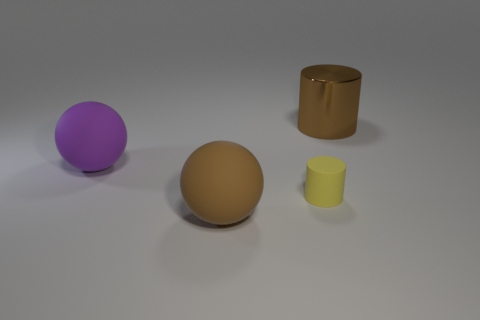Add 1 brown metallic cylinders. How many objects exist? 5 Add 4 spheres. How many spheres exist? 6 Subtract 0 cyan cylinders. How many objects are left? 4 Subtract all big purple balls. Subtract all small yellow cylinders. How many objects are left? 2 Add 4 brown metallic objects. How many brown metallic objects are left? 5 